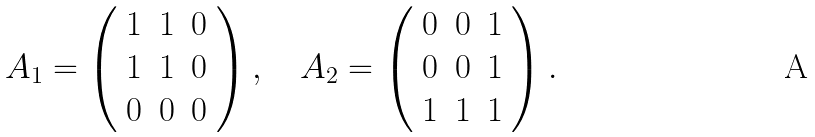Convert formula to latex. <formula><loc_0><loc_0><loc_500><loc_500>A _ { 1 } = \left ( \begin{array} { c c c } 1 & 1 & 0 \\ 1 & 1 & 0 \\ 0 & 0 & 0 \end{array} \right ) , \quad A _ { 2 } = \left ( \begin{array} { c c c } 0 & 0 & 1 \\ 0 & 0 & 1 \\ 1 & 1 & 1 \end{array} \right ) .</formula> 